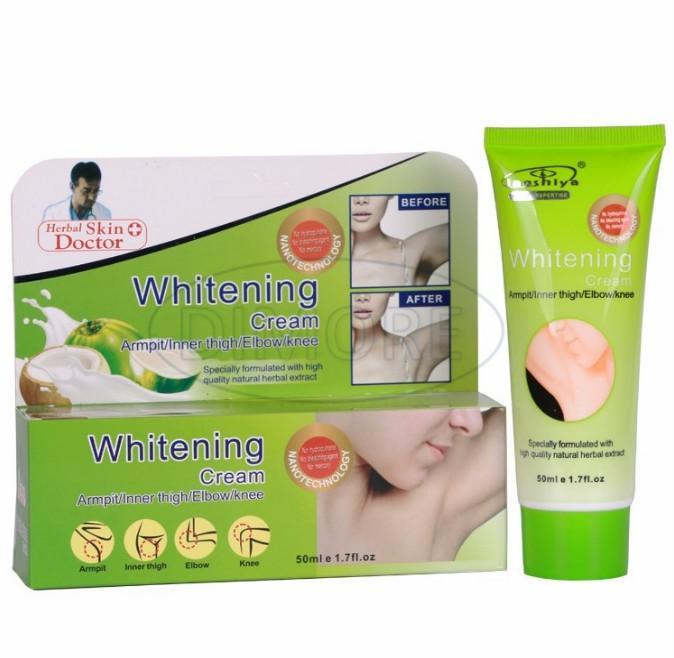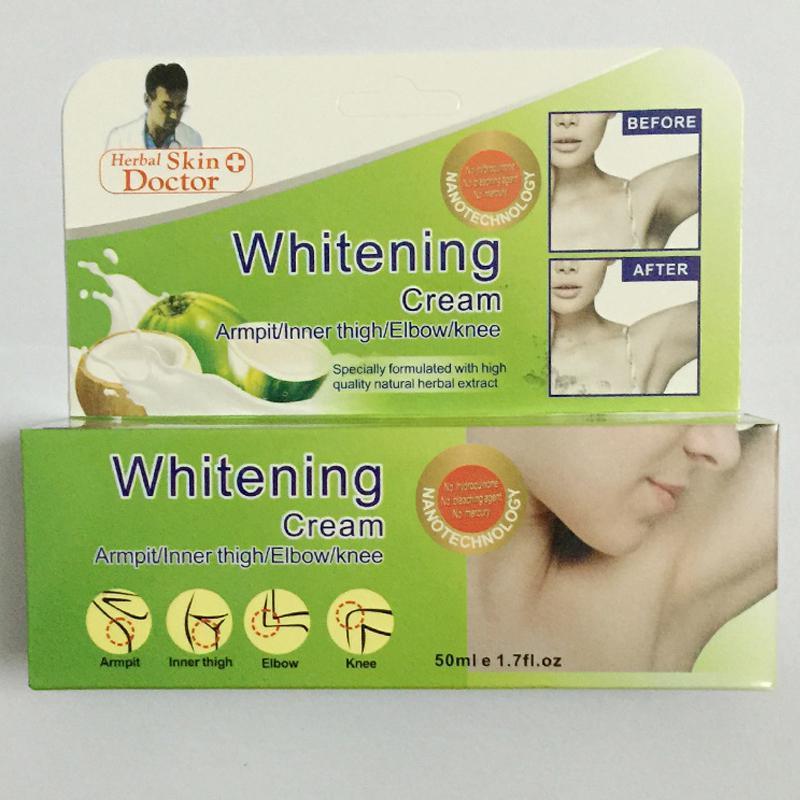The first image is the image on the left, the second image is the image on the right. Given the left and right images, does the statement "A box and a tube of whitening cream are in one image." hold true? Answer yes or no. Yes. 